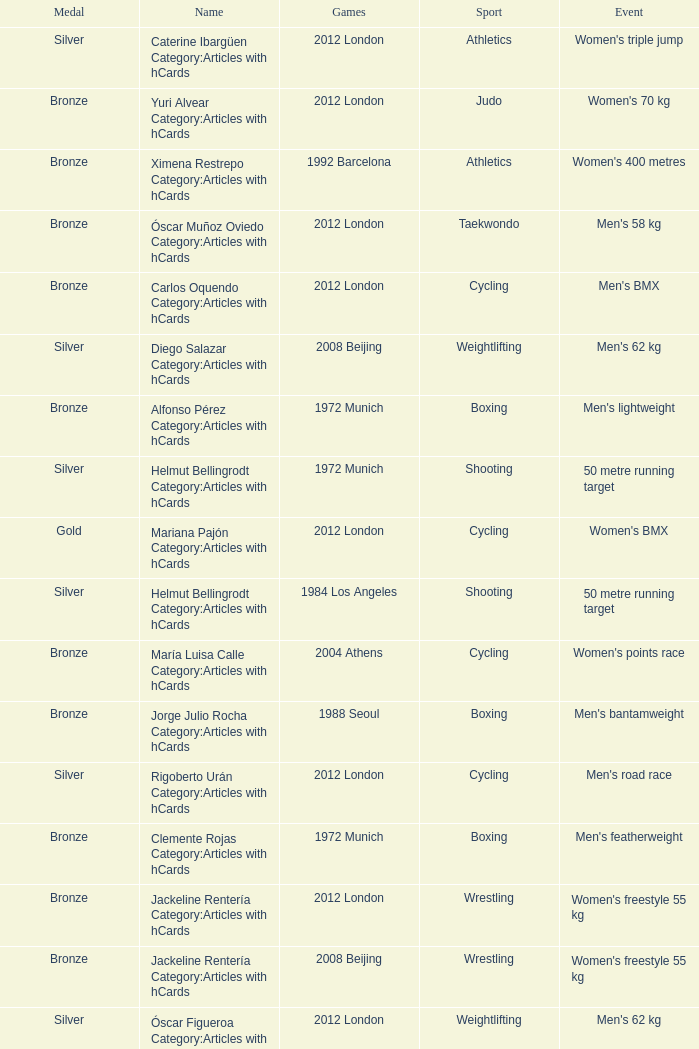Parse the table in full. {'header': ['Medal', 'Name', 'Games', 'Sport', 'Event'], 'rows': [['Silver', 'Caterine Ibargüen Category:Articles with hCards', '2012 London', 'Athletics', "Women's triple jump"], ['Bronze', 'Yuri Alvear Category:Articles with hCards', '2012 London', 'Judo', "Women's 70 kg"], ['Bronze', 'Ximena Restrepo Category:Articles with hCards', '1992 Barcelona', 'Athletics', "Women's 400 metres"], ['Bronze', 'Óscar Muñoz Oviedo Category:Articles with hCards', '2012 London', 'Taekwondo', "Men's 58 kg"], ['Bronze', 'Carlos Oquendo Category:Articles with hCards', '2012 London', 'Cycling', "Men's BMX"], ['Silver', 'Diego Salazar Category:Articles with hCards', '2008 Beijing', 'Weightlifting', "Men's 62 kg"], ['Bronze', 'Alfonso Pérez Category:Articles with hCards', '1972 Munich', 'Boxing', "Men's lightweight"], ['Silver', 'Helmut Bellingrodt Category:Articles with hCards', '1972 Munich', 'Shooting', '50 metre running target'], ['Gold', 'Mariana Pajón Category:Articles with hCards', '2012 London', 'Cycling', "Women's BMX"], ['Silver', 'Helmut Bellingrodt Category:Articles with hCards', '1984 Los Angeles', 'Shooting', '50 metre running target'], ['Bronze', 'María Luisa Calle Category:Articles with hCards', '2004 Athens', 'Cycling', "Women's points race"], ['Bronze', 'Jorge Julio Rocha Category:Articles with hCards', '1988 Seoul', 'Boxing', "Men's bantamweight"], ['Silver', 'Rigoberto Urán Category:Articles with hCards', '2012 London', 'Cycling', "Men's road race"], ['Bronze', 'Clemente Rojas Category:Articles with hCards', '1972 Munich', 'Boxing', "Men's featherweight"], ['Bronze', 'Jackeline Rentería Category:Articles with hCards', '2012 London', 'Wrestling', "Women's freestyle 55 kg"], ['Bronze', 'Jackeline Rentería Category:Articles with hCards', '2008 Beijing', 'Wrestling', "Women's freestyle 55 kg"], ['Silver', 'Óscar Figueroa Category:Articles with hCards', '2012 London', 'Weightlifting', "Men's 62 kg"], ['Gold', 'María Isabel Urrutia Category:Articles with hCards', '2000 Sydney', 'Weightlifting', "Women's 75kg"], ['Bronze', 'Mabel Mosquera Category:Articles with hCards', '2004 Athens', 'Weightlifting', "Women's 53 kg"]]} What wrestling event was participated in during the 2008 Beijing games? Women's freestyle 55 kg. 